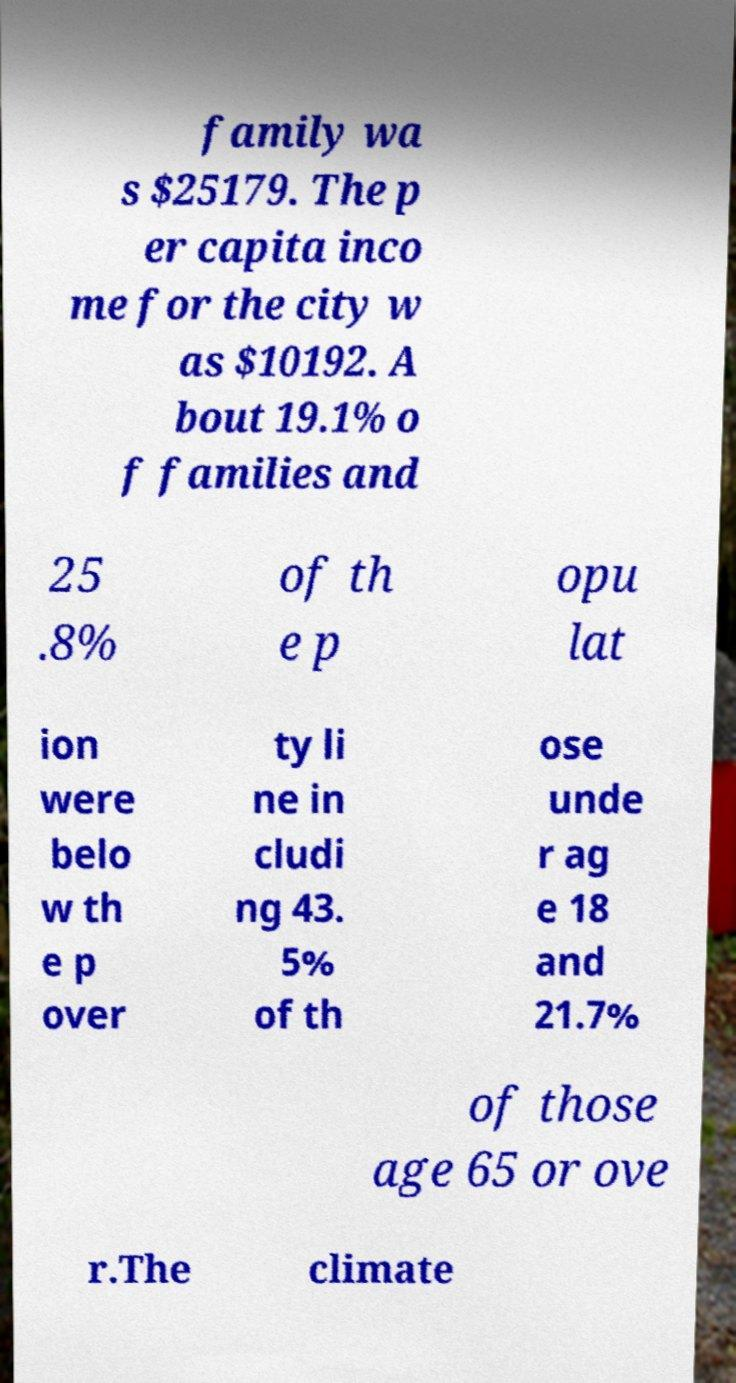For documentation purposes, I need the text within this image transcribed. Could you provide that? family wa s $25179. The p er capita inco me for the city w as $10192. A bout 19.1% o f families and 25 .8% of th e p opu lat ion were belo w th e p over ty li ne in cludi ng 43. 5% of th ose unde r ag e 18 and 21.7% of those age 65 or ove r.The climate 